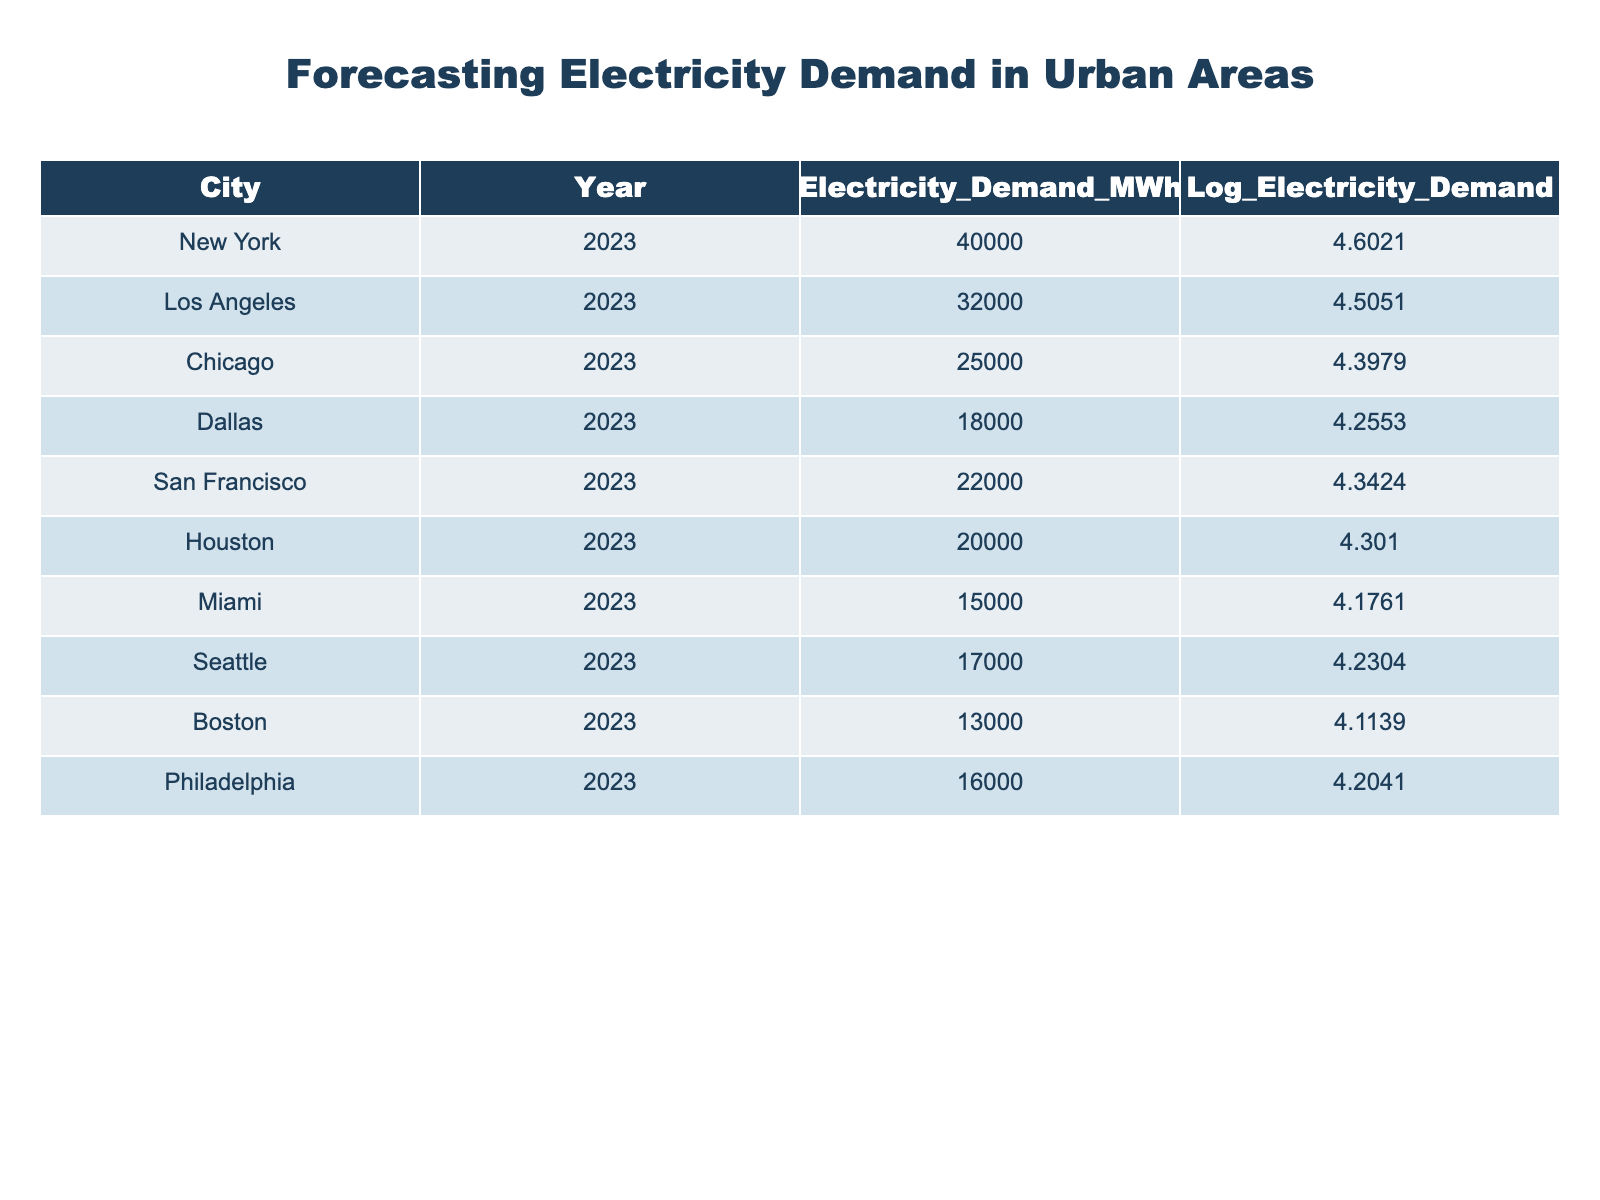What is the electricity demand in New York for 2023? The table shows that the electricity demand in New York for the year 2023 is given directly. Referring to the row for New York, the value is 40000 MWh.
Answer: 40000 MWh Which city has the highest electricity demand in 2023? By examining the electricity demand values in the table, New York has the highest demand at 40000 MWh.
Answer: New York What is the total electricity demand for all cities listed? To find the total, we sum the electricity demand values for all cities: 40000 + 32000 + 25000 + 18000 + 22000 + 20000 + 15000 + 17000 + 13000 + 16000 = 197000 MWh.
Answer: 197000 MWh Is Chicago's electricity demand greater than Miami's? Comparing the values, Chicago's electricity demand is 25000 MWh while Miami's is 15000 MWh. Since 25000 is greater than 15000, the statement is true.
Answer: Yes What is the average electricity demand across all cities? To find the average, we first sum all the electricity demand values (197000 MWh) and then divide by the number of cities (10). Thus, 197000 / 10 = 19700 MWh is the average.
Answer: 19700 MWh Which city has the lowest logarithmic electricity demand value? Referring to the logarithmic values, Boston has the lowest at 4.1139.
Answer: Boston What is the difference in electricity demand between Los Angeles and Dallas? Los Angeles has an electricity demand of 32000 MWh and Dallas has 18000 MWh. The difference is 32000 - 18000 = 14000 MWh.
Answer: 14000 MWh Is the logarithmic electricity demand for San Francisco greater than that for Miami? Looking at the logarithmic values, San Francisco's is 4.3424 and Miami's is 4.1761. Since 4.3424 is greater than 4.1761, the answer is yes.
Answer: Yes What is the median of the electricity demands recorded in the table? First, we list the electricity demands in ascending order: 15000, 16000, 17000, 18000, 22000, 25000, 32000, 40000. Since there are 10 values, the median will be the average of the 5th and 6th values: (22000 + 25000) / 2 = 23500 MWh.
Answer: 23500 MWh 